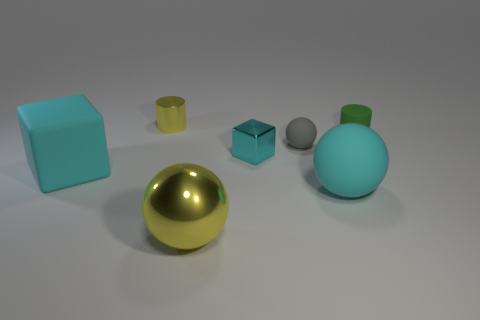There is a small thing that is made of the same material as the small green cylinder; what is its shape?
Make the answer very short. Sphere. How many other objects are the same shape as the large yellow object?
Give a very brief answer. 2. What is the shape of the cyan thing on the right side of the small gray sphere left of the cyan thing that is to the right of the tiny gray object?
Ensure brevity in your answer.  Sphere. What number of cubes are big metallic objects or big brown matte things?
Your response must be concise. 0. Is there a cyan matte object on the left side of the yellow thing that is in front of the green rubber cylinder?
Offer a terse response. Yes. There is a tiny gray rubber object; is it the same shape as the yellow object that is in front of the small yellow metal object?
Keep it short and to the point. Yes. How many other things are there of the same size as the rubber cylinder?
Keep it short and to the point. 3. How many brown objects are either balls or tiny cubes?
Offer a terse response. 0. What number of cylinders are to the left of the gray thing and in front of the yellow shiny cylinder?
Keep it short and to the point. 0. There is a cylinder right of the yellow metal object behind the matte object that is on the right side of the big cyan matte ball; what is it made of?
Your answer should be very brief. Rubber. 